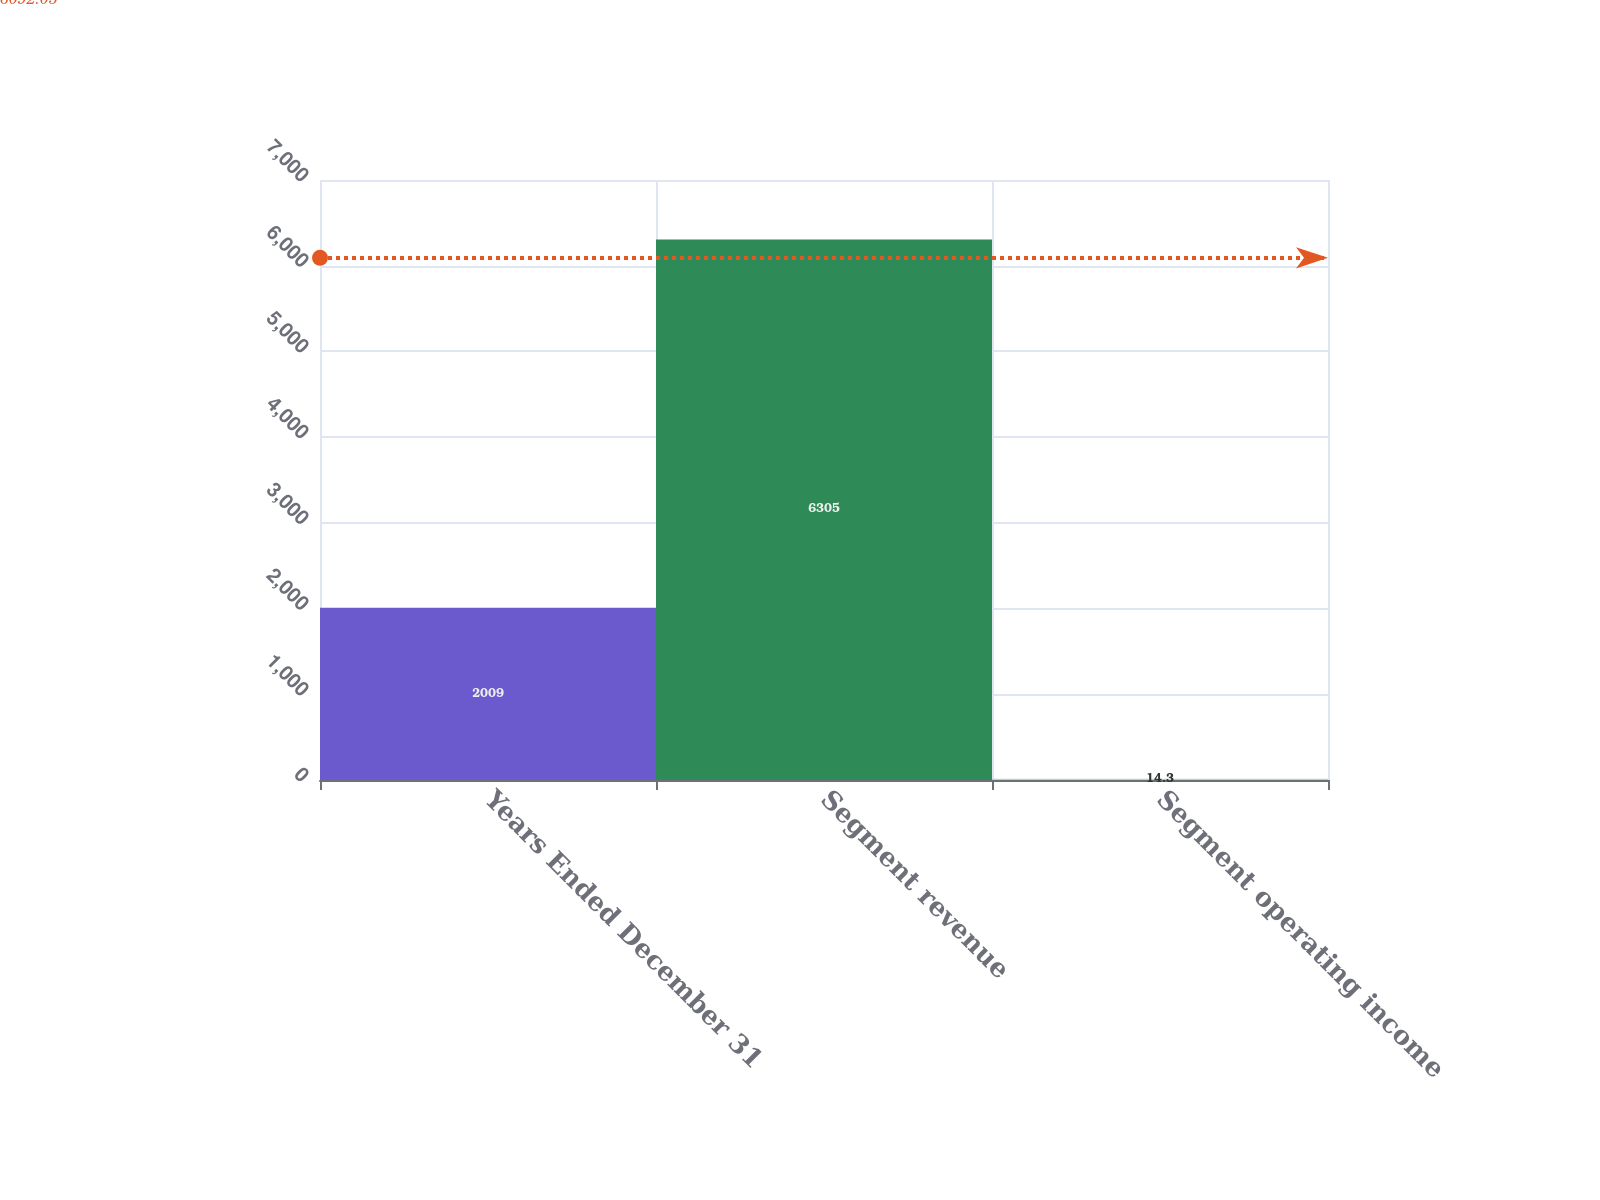Convert chart. <chart><loc_0><loc_0><loc_500><loc_500><bar_chart><fcel>Years Ended December 31<fcel>Segment revenue<fcel>Segment operating income<nl><fcel>2009<fcel>6305<fcel>14.3<nl></chart> 